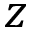Convert formula to latex. <formula><loc_0><loc_0><loc_500><loc_500>z</formula> 